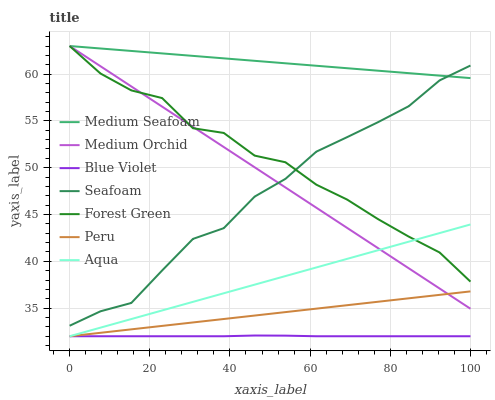Does Blue Violet have the minimum area under the curve?
Answer yes or no. Yes. Does Medium Seafoam have the maximum area under the curve?
Answer yes or no. Yes. Does Aqua have the minimum area under the curve?
Answer yes or no. No. Does Aqua have the maximum area under the curve?
Answer yes or no. No. Is Medium Seafoam the smoothest?
Answer yes or no. Yes. Is Forest Green the roughest?
Answer yes or no. Yes. Is Aqua the smoothest?
Answer yes or no. No. Is Aqua the roughest?
Answer yes or no. No. Does Seafoam have the lowest value?
Answer yes or no. No. Does Medium Seafoam have the highest value?
Answer yes or no. Yes. Does Aqua have the highest value?
Answer yes or no. No. Is Peru less than Seafoam?
Answer yes or no. Yes. Is Medium Seafoam greater than Peru?
Answer yes or no. Yes. Does Medium Seafoam intersect Medium Orchid?
Answer yes or no. Yes. Is Medium Seafoam less than Medium Orchid?
Answer yes or no. No. Is Medium Seafoam greater than Medium Orchid?
Answer yes or no. No. Does Peru intersect Seafoam?
Answer yes or no. No. 